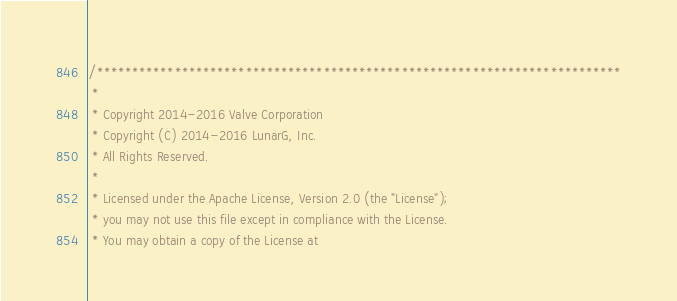Convert code to text. <code><loc_0><loc_0><loc_500><loc_500><_C_>/**************************************************************************
 *
 * Copyright 2014-2016 Valve Corporation
 * Copyright (C) 2014-2016 LunarG, Inc.
 * All Rights Reserved.
 *
 * Licensed under the Apache License, Version 2.0 (the "License");
 * you may not use this file except in compliance with the License.
 * You may obtain a copy of the License at</code> 